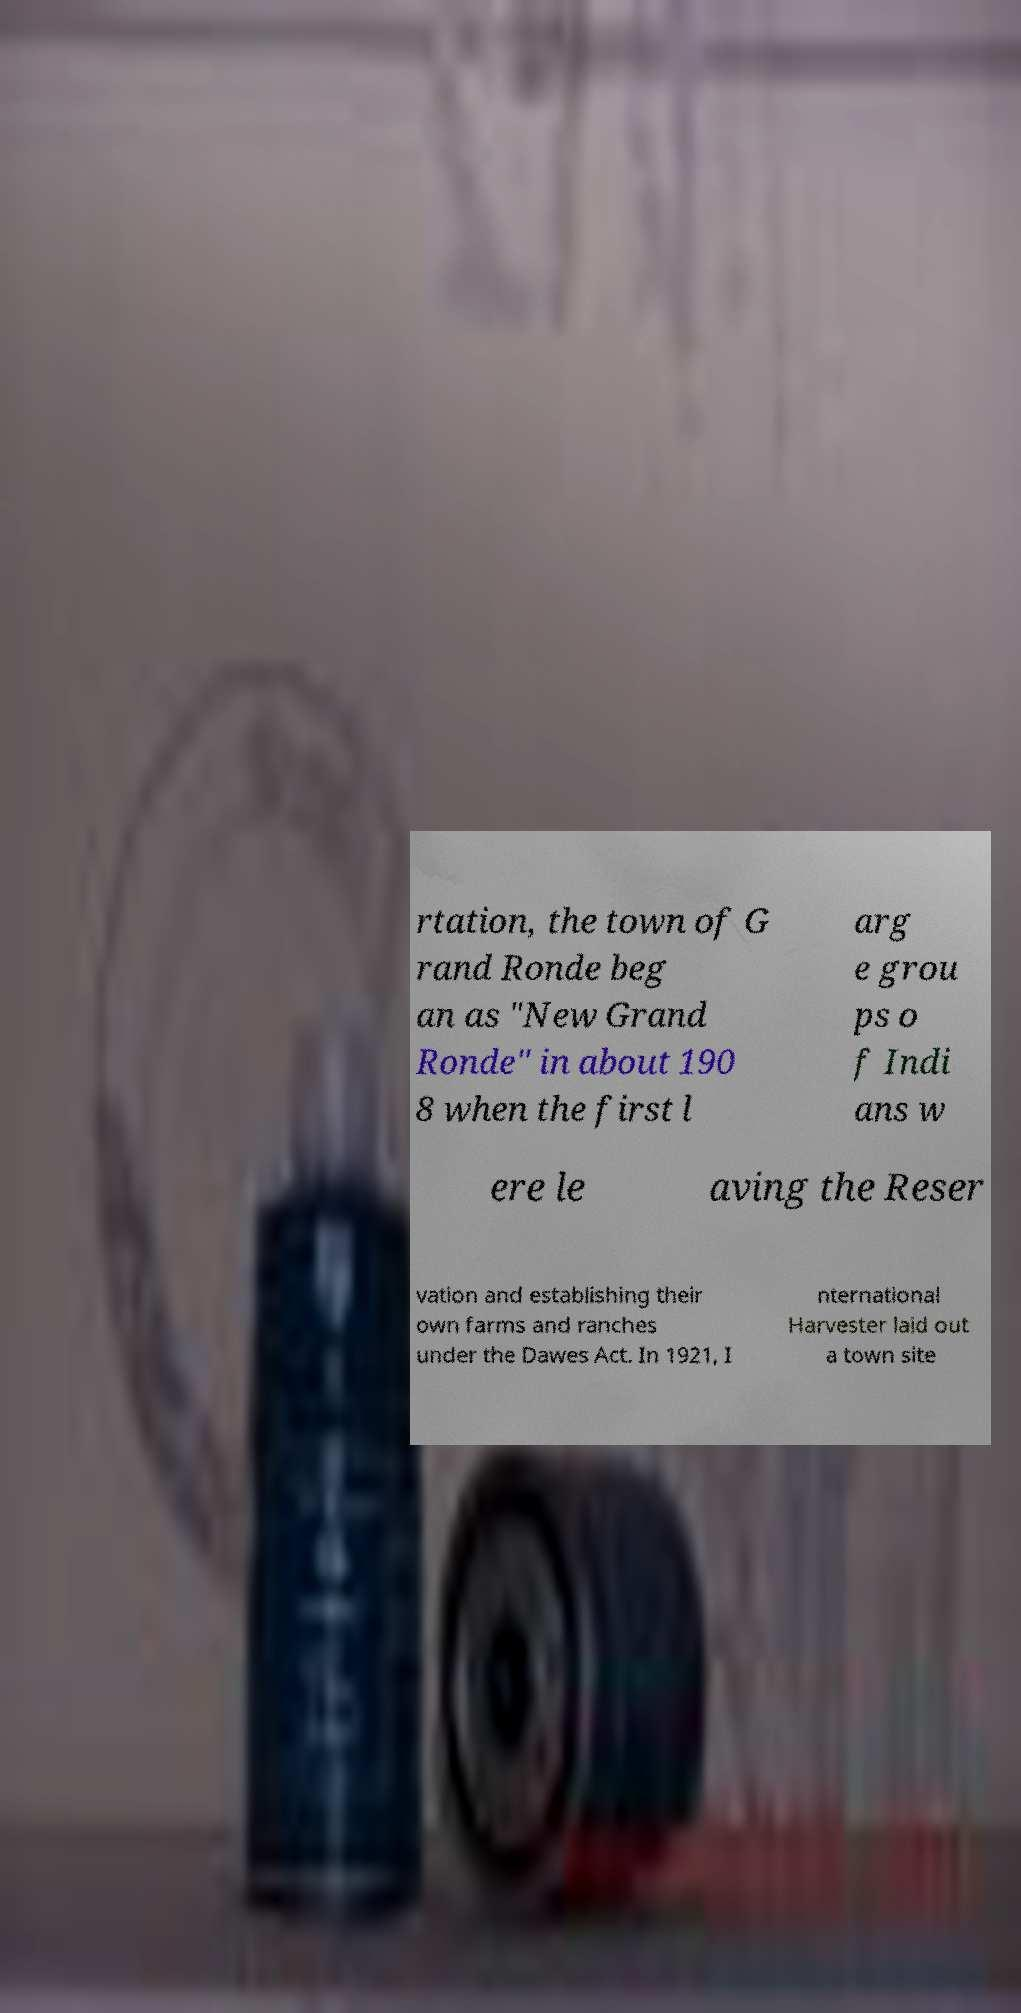What messages or text are displayed in this image? I need them in a readable, typed format. rtation, the town of G rand Ronde beg an as "New Grand Ronde" in about 190 8 when the first l arg e grou ps o f Indi ans w ere le aving the Reser vation and establishing their own farms and ranches under the Dawes Act. In 1921, I nternational Harvester laid out a town site 